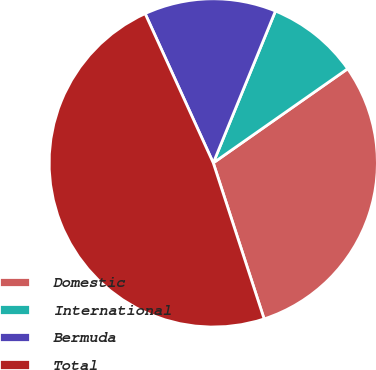Convert chart to OTSL. <chart><loc_0><loc_0><loc_500><loc_500><pie_chart><fcel>Domestic<fcel>International<fcel>Bermuda<fcel>Total<nl><fcel>29.71%<fcel>9.09%<fcel>13.0%<fcel>48.2%<nl></chart> 